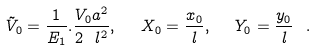<formula> <loc_0><loc_0><loc_500><loc_500>\tilde { V } _ { 0 } = \frac { 1 } { E _ { 1 } } . \frac { V _ { 0 } a ^ { 2 } } { 2 \ l ^ { 2 } } , \ \ X _ { 0 } = \frac { x _ { 0 } } { l } , \ \ Y _ { 0 } = \frac { y _ { 0 } } { l } \ .</formula> 